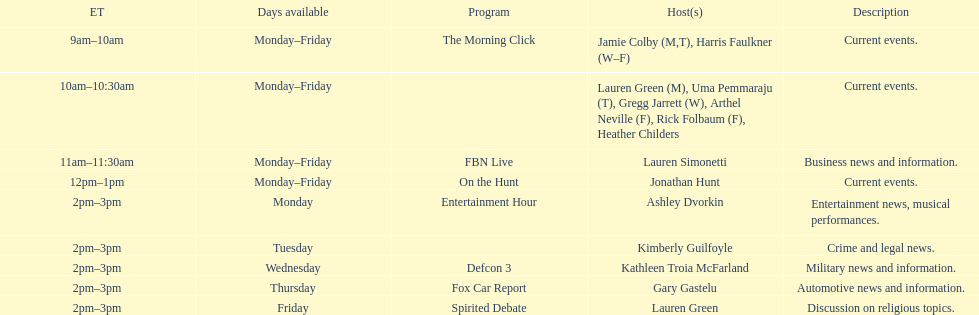On how many weekdays does fbn live air their show? 5. 